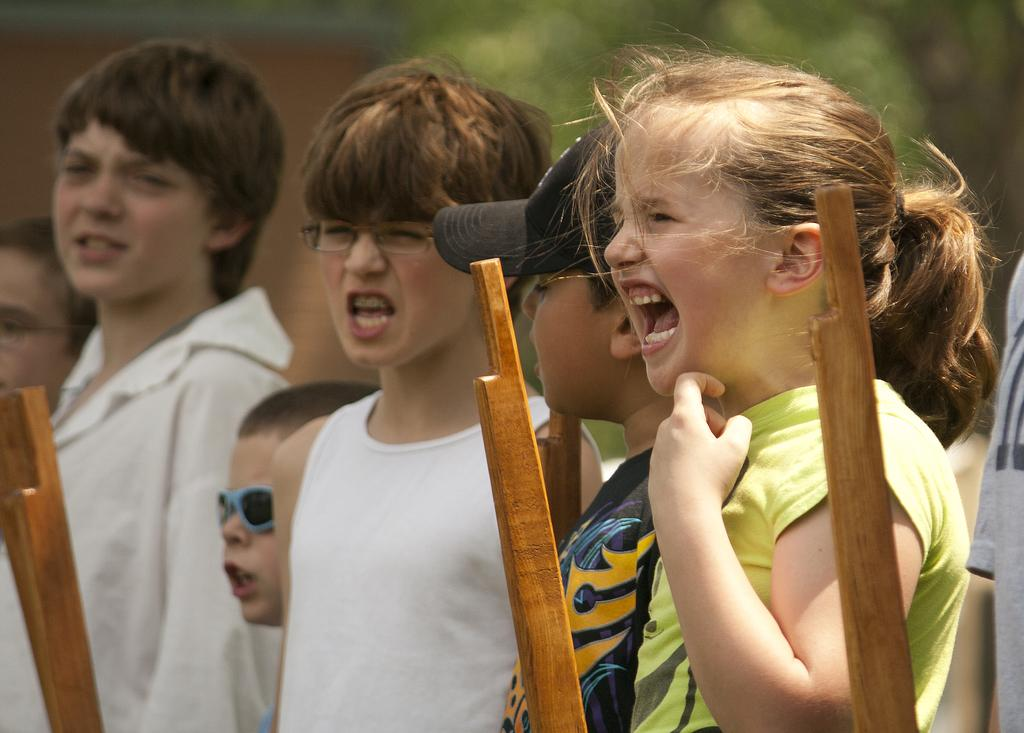What is the main subject of the image? The main subject of the image is kids standing. What objects can be seen in the image besides the kids? There are sticks visible in the image. What colors are present in the background of the image? The background of the image has blue and green colors. What time of day is it in the image, as indicated by the hour? There is no hour or time of day indicated in the image. Can you compare the size of the kids to the size of the sticks in the image? The provided facts do not include any information about the size of the kids or the sticks, so it is not possible to make a comparison. Was there an earthquake in the image, as indicated by the blue and green colors in the background? There is no indication of an earthquake in the image; the blue and green colors in the background are likely due to the presence of sky and vegetation. 